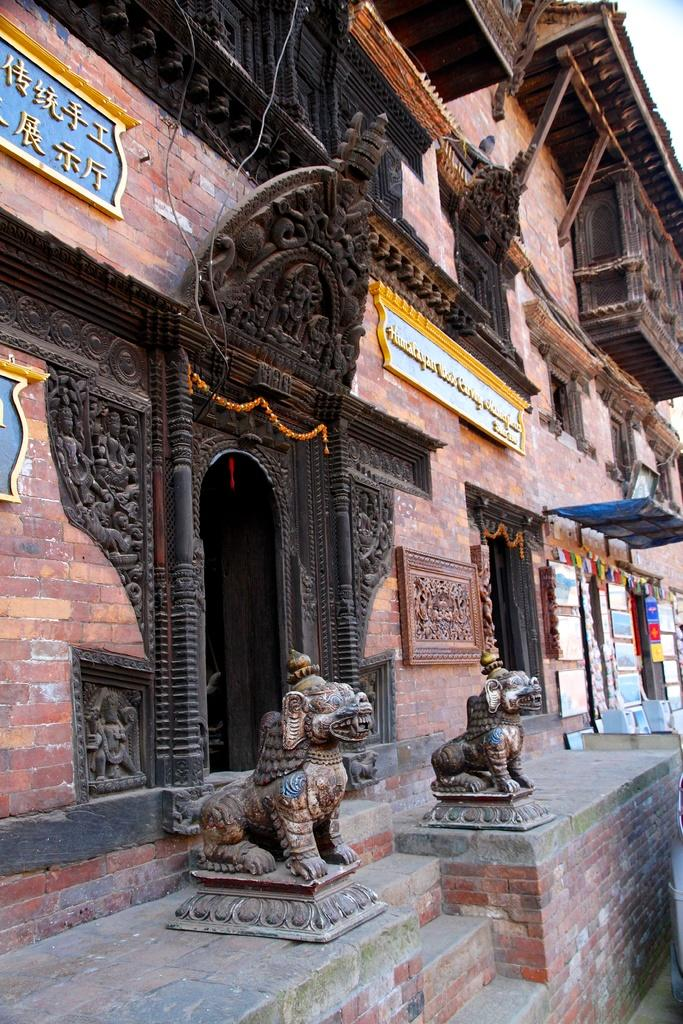What type of structure is depicted in the image? There is a building with many boards in the image. What can be seen in front of the building? There are statues of animals in front of the building. What is visible in the background of the image? The sky is visible in the background of the image. What type of cord is hanging from the tree in the image? There is no tree or cord present in the image; it features a building with many boards and statues of animals in front. 